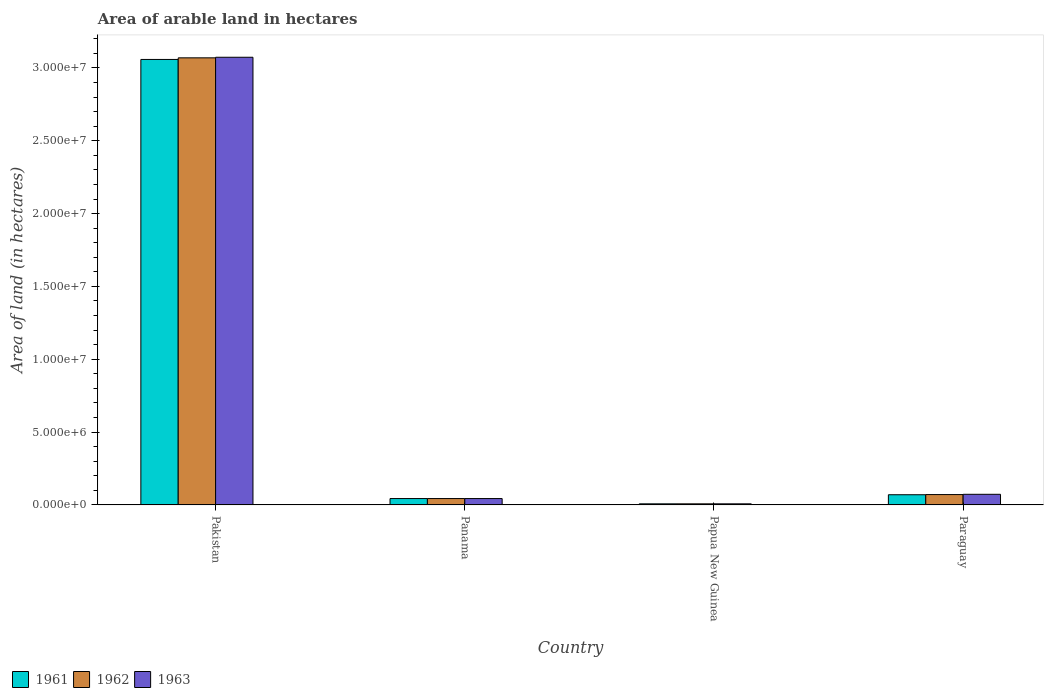How many different coloured bars are there?
Offer a terse response. 3. Are the number of bars per tick equal to the number of legend labels?
Make the answer very short. Yes. What is the label of the 3rd group of bars from the left?
Your answer should be compact. Papua New Guinea. What is the total arable land in 1963 in Panama?
Your answer should be very brief. 4.38e+05. Across all countries, what is the maximum total arable land in 1961?
Provide a succinct answer. 3.06e+07. Across all countries, what is the minimum total arable land in 1962?
Your response must be concise. 7.50e+04. In which country was the total arable land in 1961 maximum?
Provide a short and direct response. Pakistan. In which country was the total arable land in 1961 minimum?
Give a very brief answer. Papua New Guinea. What is the total total arable land in 1961 in the graph?
Offer a very short reply. 3.18e+07. What is the difference between the total arable land in 1961 in Pakistan and that in Papua New Guinea?
Keep it short and to the point. 3.05e+07. What is the difference between the total arable land in 1961 in Papua New Guinea and the total arable land in 1962 in Paraguay?
Make the answer very short. -6.36e+05. What is the average total arable land in 1962 per country?
Offer a terse response. 7.98e+06. What is the difference between the total arable land of/in 1963 and total arable land of/in 1961 in Paraguay?
Your answer should be compact. 2.90e+04. In how many countries, is the total arable land in 1962 greater than 4000000 hectares?
Provide a succinct answer. 1. What is the ratio of the total arable land in 1962 in Panama to that in Papua New Guinea?
Your response must be concise. 5.84. Is the total arable land in 1961 in Papua New Guinea less than that in Paraguay?
Your answer should be compact. Yes. What is the difference between the highest and the second highest total arable land in 1962?
Ensure brevity in your answer.  3.00e+07. What is the difference between the highest and the lowest total arable land in 1963?
Provide a short and direct response. 3.07e+07. What does the 1st bar from the right in Papua New Guinea represents?
Offer a terse response. 1963. Are all the bars in the graph horizontal?
Make the answer very short. No. What is the difference between two consecutive major ticks on the Y-axis?
Offer a very short reply. 5.00e+06. Does the graph contain any zero values?
Keep it short and to the point. No. Does the graph contain grids?
Make the answer very short. No. Where does the legend appear in the graph?
Ensure brevity in your answer.  Bottom left. How many legend labels are there?
Make the answer very short. 3. What is the title of the graph?
Make the answer very short. Area of arable land in hectares. What is the label or title of the Y-axis?
Your answer should be compact. Area of land (in hectares). What is the Area of land (in hectares) of 1961 in Pakistan?
Your answer should be compact. 3.06e+07. What is the Area of land (in hectares) of 1962 in Pakistan?
Provide a succinct answer. 3.07e+07. What is the Area of land (in hectares) in 1963 in Pakistan?
Provide a succinct answer. 3.07e+07. What is the Area of land (in hectares) of 1961 in Panama?
Keep it short and to the point. 4.38e+05. What is the Area of land (in hectares) in 1962 in Panama?
Give a very brief answer. 4.38e+05. What is the Area of land (in hectares) of 1963 in Panama?
Your answer should be compact. 4.38e+05. What is the Area of land (in hectares) in 1961 in Papua New Guinea?
Offer a terse response. 7.50e+04. What is the Area of land (in hectares) in 1962 in Papua New Guinea?
Provide a succinct answer. 7.50e+04. What is the Area of land (in hectares) in 1963 in Papua New Guinea?
Ensure brevity in your answer.  7.50e+04. What is the Area of land (in hectares) in 1962 in Paraguay?
Keep it short and to the point. 7.11e+05. What is the Area of land (in hectares) in 1963 in Paraguay?
Ensure brevity in your answer.  7.29e+05. Across all countries, what is the maximum Area of land (in hectares) in 1961?
Give a very brief answer. 3.06e+07. Across all countries, what is the maximum Area of land (in hectares) in 1962?
Provide a short and direct response. 3.07e+07. Across all countries, what is the maximum Area of land (in hectares) in 1963?
Offer a very short reply. 3.07e+07. Across all countries, what is the minimum Area of land (in hectares) of 1961?
Provide a short and direct response. 7.50e+04. Across all countries, what is the minimum Area of land (in hectares) of 1962?
Offer a terse response. 7.50e+04. Across all countries, what is the minimum Area of land (in hectares) in 1963?
Your answer should be compact. 7.50e+04. What is the total Area of land (in hectares) in 1961 in the graph?
Give a very brief answer. 3.18e+07. What is the total Area of land (in hectares) of 1962 in the graph?
Keep it short and to the point. 3.19e+07. What is the total Area of land (in hectares) in 1963 in the graph?
Offer a very short reply. 3.20e+07. What is the difference between the Area of land (in hectares) in 1961 in Pakistan and that in Panama?
Offer a terse response. 3.01e+07. What is the difference between the Area of land (in hectares) of 1962 in Pakistan and that in Panama?
Offer a very short reply. 3.03e+07. What is the difference between the Area of land (in hectares) in 1963 in Pakistan and that in Panama?
Ensure brevity in your answer.  3.03e+07. What is the difference between the Area of land (in hectares) of 1961 in Pakistan and that in Papua New Guinea?
Your answer should be very brief. 3.05e+07. What is the difference between the Area of land (in hectares) of 1962 in Pakistan and that in Papua New Guinea?
Ensure brevity in your answer.  3.06e+07. What is the difference between the Area of land (in hectares) in 1963 in Pakistan and that in Papua New Guinea?
Make the answer very short. 3.07e+07. What is the difference between the Area of land (in hectares) of 1961 in Pakistan and that in Paraguay?
Your answer should be compact. 2.99e+07. What is the difference between the Area of land (in hectares) of 1962 in Pakistan and that in Paraguay?
Provide a succinct answer. 3.00e+07. What is the difference between the Area of land (in hectares) of 1963 in Pakistan and that in Paraguay?
Provide a succinct answer. 3.00e+07. What is the difference between the Area of land (in hectares) of 1961 in Panama and that in Papua New Guinea?
Ensure brevity in your answer.  3.63e+05. What is the difference between the Area of land (in hectares) of 1962 in Panama and that in Papua New Guinea?
Make the answer very short. 3.63e+05. What is the difference between the Area of land (in hectares) in 1963 in Panama and that in Papua New Guinea?
Your response must be concise. 3.63e+05. What is the difference between the Area of land (in hectares) of 1961 in Panama and that in Paraguay?
Your answer should be very brief. -2.62e+05. What is the difference between the Area of land (in hectares) of 1962 in Panama and that in Paraguay?
Keep it short and to the point. -2.73e+05. What is the difference between the Area of land (in hectares) of 1963 in Panama and that in Paraguay?
Provide a succinct answer. -2.91e+05. What is the difference between the Area of land (in hectares) of 1961 in Papua New Guinea and that in Paraguay?
Offer a terse response. -6.25e+05. What is the difference between the Area of land (in hectares) in 1962 in Papua New Guinea and that in Paraguay?
Your answer should be compact. -6.36e+05. What is the difference between the Area of land (in hectares) in 1963 in Papua New Guinea and that in Paraguay?
Your answer should be compact. -6.54e+05. What is the difference between the Area of land (in hectares) in 1961 in Pakistan and the Area of land (in hectares) in 1962 in Panama?
Your response must be concise. 3.01e+07. What is the difference between the Area of land (in hectares) of 1961 in Pakistan and the Area of land (in hectares) of 1963 in Panama?
Offer a very short reply. 3.01e+07. What is the difference between the Area of land (in hectares) in 1962 in Pakistan and the Area of land (in hectares) in 1963 in Panama?
Keep it short and to the point. 3.03e+07. What is the difference between the Area of land (in hectares) in 1961 in Pakistan and the Area of land (in hectares) in 1962 in Papua New Guinea?
Provide a short and direct response. 3.05e+07. What is the difference between the Area of land (in hectares) of 1961 in Pakistan and the Area of land (in hectares) of 1963 in Papua New Guinea?
Make the answer very short. 3.05e+07. What is the difference between the Area of land (in hectares) of 1962 in Pakistan and the Area of land (in hectares) of 1963 in Papua New Guinea?
Your answer should be compact. 3.06e+07. What is the difference between the Area of land (in hectares) of 1961 in Pakistan and the Area of land (in hectares) of 1962 in Paraguay?
Ensure brevity in your answer.  2.99e+07. What is the difference between the Area of land (in hectares) in 1961 in Pakistan and the Area of land (in hectares) in 1963 in Paraguay?
Offer a terse response. 2.99e+07. What is the difference between the Area of land (in hectares) in 1962 in Pakistan and the Area of land (in hectares) in 1963 in Paraguay?
Offer a terse response. 3.00e+07. What is the difference between the Area of land (in hectares) in 1961 in Panama and the Area of land (in hectares) in 1962 in Papua New Guinea?
Keep it short and to the point. 3.63e+05. What is the difference between the Area of land (in hectares) of 1961 in Panama and the Area of land (in hectares) of 1963 in Papua New Guinea?
Your answer should be very brief. 3.63e+05. What is the difference between the Area of land (in hectares) of 1962 in Panama and the Area of land (in hectares) of 1963 in Papua New Guinea?
Ensure brevity in your answer.  3.63e+05. What is the difference between the Area of land (in hectares) of 1961 in Panama and the Area of land (in hectares) of 1962 in Paraguay?
Your answer should be very brief. -2.73e+05. What is the difference between the Area of land (in hectares) of 1961 in Panama and the Area of land (in hectares) of 1963 in Paraguay?
Provide a short and direct response. -2.91e+05. What is the difference between the Area of land (in hectares) in 1962 in Panama and the Area of land (in hectares) in 1963 in Paraguay?
Provide a short and direct response. -2.91e+05. What is the difference between the Area of land (in hectares) in 1961 in Papua New Guinea and the Area of land (in hectares) in 1962 in Paraguay?
Your response must be concise. -6.36e+05. What is the difference between the Area of land (in hectares) of 1961 in Papua New Guinea and the Area of land (in hectares) of 1963 in Paraguay?
Your answer should be very brief. -6.54e+05. What is the difference between the Area of land (in hectares) in 1962 in Papua New Guinea and the Area of land (in hectares) in 1963 in Paraguay?
Provide a succinct answer. -6.54e+05. What is the average Area of land (in hectares) of 1961 per country?
Provide a short and direct response. 7.95e+06. What is the average Area of land (in hectares) in 1962 per country?
Keep it short and to the point. 7.98e+06. What is the average Area of land (in hectares) of 1963 per country?
Your response must be concise. 7.99e+06. What is the difference between the Area of land (in hectares) in 1961 and Area of land (in hectares) in 1962 in Pakistan?
Keep it short and to the point. -1.10e+05. What is the difference between the Area of land (in hectares) of 1961 and Area of land (in hectares) of 1963 in Pakistan?
Your response must be concise. -1.50e+05. What is the difference between the Area of land (in hectares) of 1961 and Area of land (in hectares) of 1962 in Panama?
Offer a very short reply. 0. What is the difference between the Area of land (in hectares) in 1961 and Area of land (in hectares) in 1963 in Panama?
Your answer should be compact. 0. What is the difference between the Area of land (in hectares) of 1961 and Area of land (in hectares) of 1963 in Papua New Guinea?
Your answer should be very brief. 0. What is the difference between the Area of land (in hectares) in 1961 and Area of land (in hectares) in 1962 in Paraguay?
Offer a terse response. -1.10e+04. What is the difference between the Area of land (in hectares) in 1961 and Area of land (in hectares) in 1963 in Paraguay?
Offer a very short reply. -2.90e+04. What is the difference between the Area of land (in hectares) in 1962 and Area of land (in hectares) in 1963 in Paraguay?
Your answer should be compact. -1.80e+04. What is the ratio of the Area of land (in hectares) of 1961 in Pakistan to that in Panama?
Your response must be concise. 69.82. What is the ratio of the Area of land (in hectares) in 1962 in Pakistan to that in Panama?
Offer a very short reply. 70.07. What is the ratio of the Area of land (in hectares) in 1963 in Pakistan to that in Panama?
Your response must be concise. 70.16. What is the ratio of the Area of land (in hectares) in 1961 in Pakistan to that in Papua New Guinea?
Your answer should be compact. 407.73. What is the ratio of the Area of land (in hectares) of 1962 in Pakistan to that in Papua New Guinea?
Offer a very short reply. 409.2. What is the ratio of the Area of land (in hectares) of 1963 in Pakistan to that in Papua New Guinea?
Make the answer very short. 409.73. What is the ratio of the Area of land (in hectares) of 1961 in Pakistan to that in Paraguay?
Provide a short and direct response. 43.69. What is the ratio of the Area of land (in hectares) in 1962 in Pakistan to that in Paraguay?
Keep it short and to the point. 43.16. What is the ratio of the Area of land (in hectares) of 1963 in Pakistan to that in Paraguay?
Your answer should be compact. 42.15. What is the ratio of the Area of land (in hectares) of 1961 in Panama to that in Papua New Guinea?
Your answer should be compact. 5.84. What is the ratio of the Area of land (in hectares) in 1962 in Panama to that in Papua New Guinea?
Keep it short and to the point. 5.84. What is the ratio of the Area of land (in hectares) of 1963 in Panama to that in Papua New Guinea?
Provide a succinct answer. 5.84. What is the ratio of the Area of land (in hectares) in 1961 in Panama to that in Paraguay?
Your response must be concise. 0.63. What is the ratio of the Area of land (in hectares) of 1962 in Panama to that in Paraguay?
Your answer should be very brief. 0.62. What is the ratio of the Area of land (in hectares) in 1963 in Panama to that in Paraguay?
Ensure brevity in your answer.  0.6. What is the ratio of the Area of land (in hectares) of 1961 in Papua New Guinea to that in Paraguay?
Provide a short and direct response. 0.11. What is the ratio of the Area of land (in hectares) of 1962 in Papua New Guinea to that in Paraguay?
Give a very brief answer. 0.11. What is the ratio of the Area of land (in hectares) in 1963 in Papua New Guinea to that in Paraguay?
Your answer should be very brief. 0.1. What is the difference between the highest and the second highest Area of land (in hectares) in 1961?
Give a very brief answer. 2.99e+07. What is the difference between the highest and the second highest Area of land (in hectares) in 1962?
Offer a terse response. 3.00e+07. What is the difference between the highest and the second highest Area of land (in hectares) in 1963?
Keep it short and to the point. 3.00e+07. What is the difference between the highest and the lowest Area of land (in hectares) in 1961?
Ensure brevity in your answer.  3.05e+07. What is the difference between the highest and the lowest Area of land (in hectares) in 1962?
Make the answer very short. 3.06e+07. What is the difference between the highest and the lowest Area of land (in hectares) in 1963?
Your answer should be compact. 3.07e+07. 